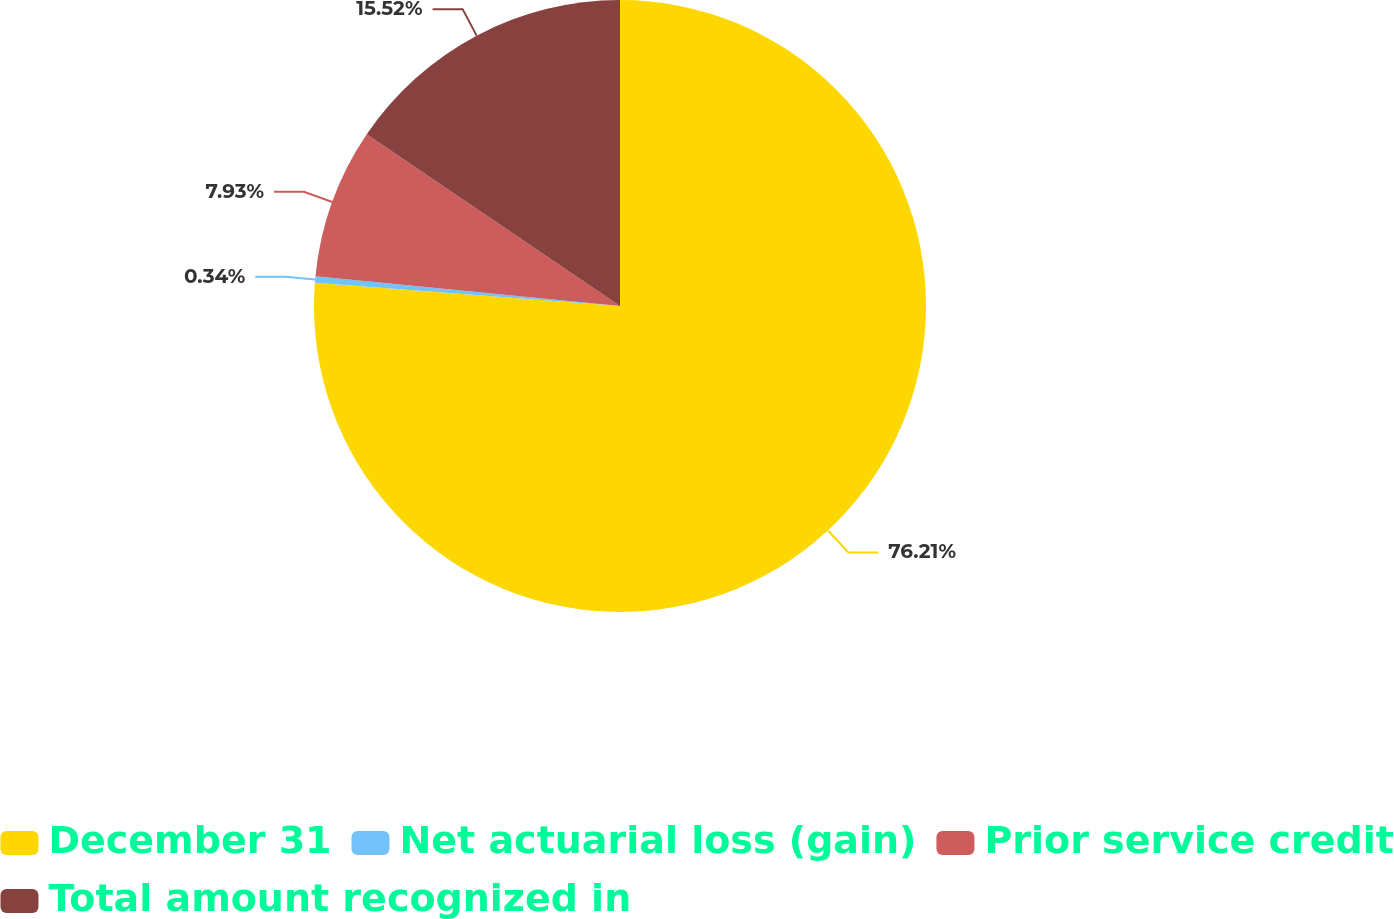Convert chart to OTSL. <chart><loc_0><loc_0><loc_500><loc_500><pie_chart><fcel>December 31<fcel>Net actuarial loss (gain)<fcel>Prior service credit<fcel>Total amount recognized in<nl><fcel>76.22%<fcel>0.34%<fcel>7.93%<fcel>15.52%<nl></chart> 